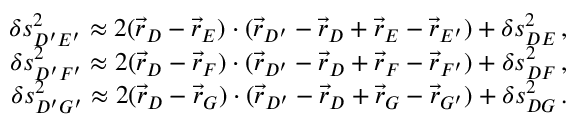Convert formula to latex. <formula><loc_0><loc_0><loc_500><loc_500>\begin{array} { r } { \delta s _ { D ^ { \prime } E ^ { \prime } } ^ { 2 } \approx 2 ( \vec { r } _ { D } - \vec { r } _ { E } ) \cdot ( \vec { r } _ { D ^ { \prime } } - \vec { r } _ { D } + \vec { r } _ { E } - \vec { r } _ { E ^ { \prime } } ) + \delta s _ { D E } ^ { 2 } \, , } \\ { \delta s _ { D ^ { \prime } F ^ { \prime } } ^ { 2 } \approx 2 ( \vec { r } _ { D } - \vec { r } _ { F } ) \cdot ( \vec { r } _ { D ^ { \prime } } - \vec { r } _ { D } + \vec { r } _ { F } - \vec { r } _ { F ^ { \prime } } ) + \delta s _ { D F } ^ { 2 } \, , } \\ { \delta s _ { D ^ { \prime } G ^ { \prime } } ^ { 2 } \approx 2 ( \vec { r } _ { D } - \vec { r } _ { G } ) \cdot ( \vec { r } _ { D ^ { \prime } } - \vec { r } _ { D } + \vec { r } _ { G } - \vec { r } _ { G ^ { \prime } } ) + \delta s _ { D G } ^ { 2 } \, . } \end{array}</formula> 